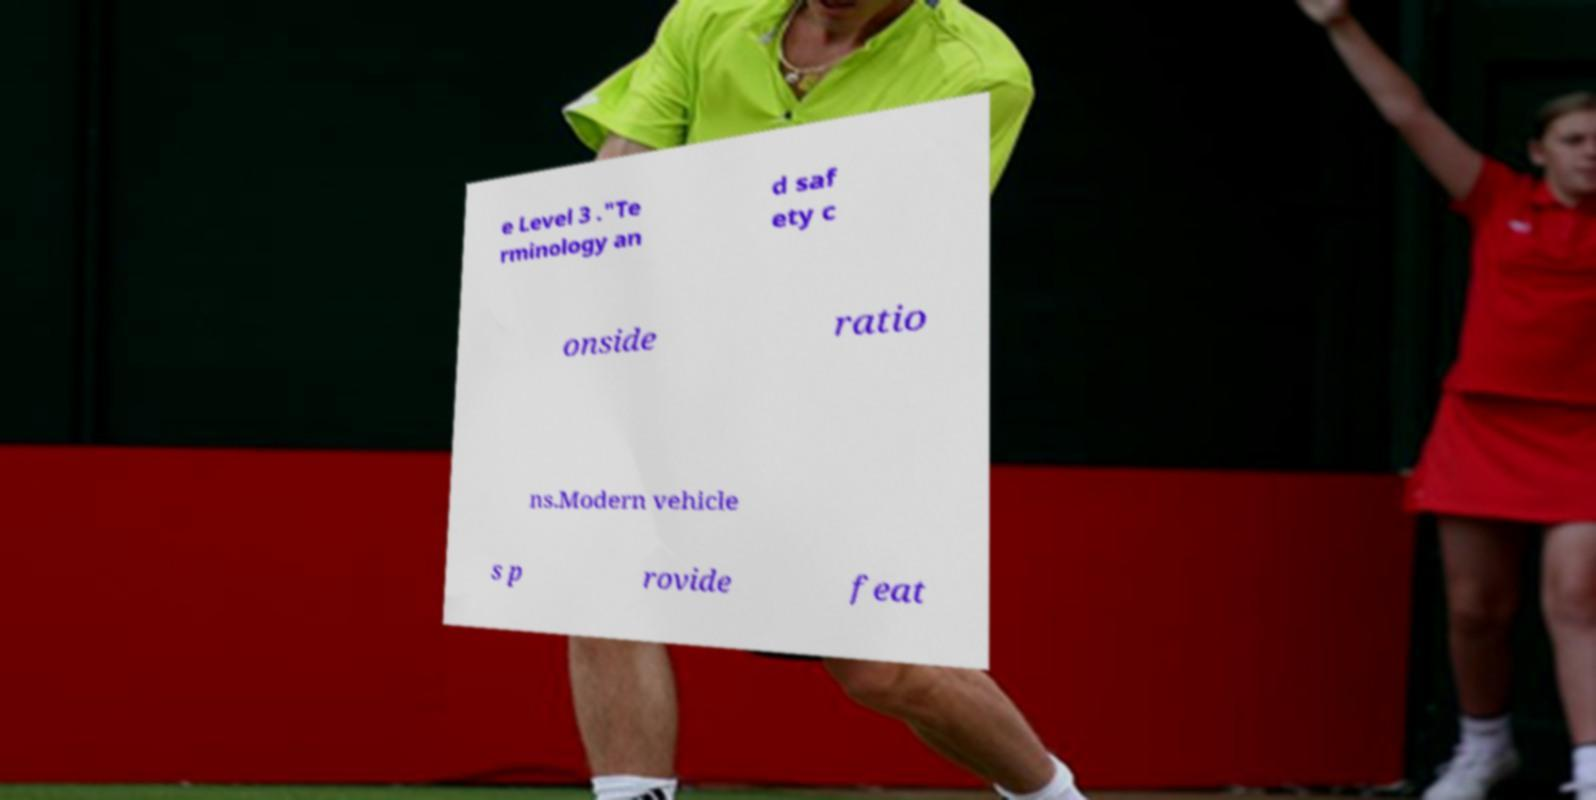Please read and relay the text visible in this image. What does it say? e Level 3 ."Te rminology an d saf ety c onside ratio ns.Modern vehicle s p rovide feat 